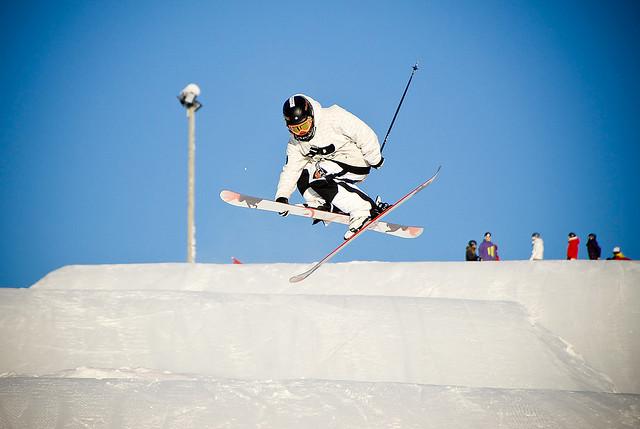How many skiers are in the air?
Keep it brief. 1. Is the person on the snowboard a man?
Write a very short answer. Yes. What color jacket is this person wearing?
Concise answer only. White. 